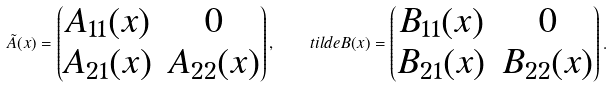Convert formula to latex. <formula><loc_0><loc_0><loc_500><loc_500>\tilde { A } ( x ) = \left ( \begin{matrix} A _ { 1 1 } ( x ) & 0 \\ A _ { 2 1 } ( x ) & A _ { 2 2 } ( x ) \end{matrix} \right ) , \quad t i l d e B ( x ) = \left ( \begin{matrix} B _ { 1 1 } ( x ) & 0 \\ B _ { 2 1 } ( x ) & B _ { 2 2 } ( x ) \end{matrix} \right ) .</formula> 